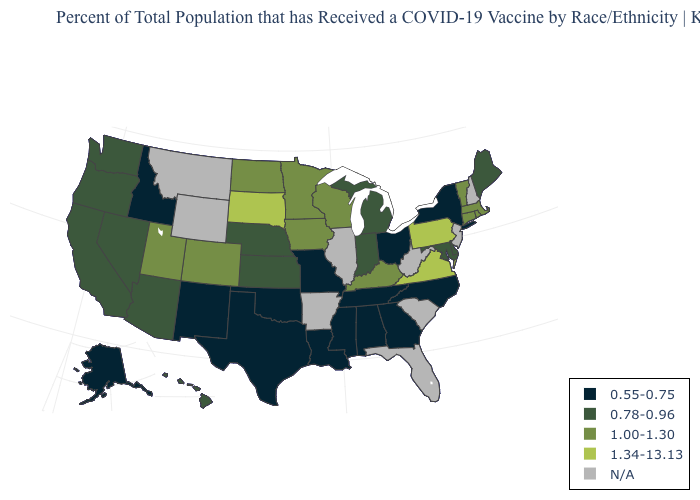What is the highest value in the USA?
Short answer required. 1.34-13.13. Does Colorado have the highest value in the West?
Give a very brief answer. Yes. What is the value of Colorado?
Be succinct. 1.00-1.30. Does Kentucky have the highest value in the South?
Short answer required. No. What is the highest value in the USA?
Quick response, please. 1.34-13.13. Which states hav the highest value in the MidWest?
Write a very short answer. South Dakota. Which states have the lowest value in the USA?
Answer briefly. Alabama, Alaska, Georgia, Idaho, Louisiana, Mississippi, Missouri, New Mexico, New York, North Carolina, Ohio, Oklahoma, Tennessee, Texas. Name the states that have a value in the range 1.00-1.30?
Write a very short answer. Colorado, Connecticut, Iowa, Kentucky, Massachusetts, Minnesota, North Dakota, Rhode Island, Utah, Vermont, Wisconsin. Name the states that have a value in the range 0.55-0.75?
Concise answer only. Alabama, Alaska, Georgia, Idaho, Louisiana, Mississippi, Missouri, New Mexico, New York, North Carolina, Ohio, Oklahoma, Tennessee, Texas. Does the map have missing data?
Write a very short answer. Yes. How many symbols are there in the legend?
Concise answer only. 5. Name the states that have a value in the range N/A?
Short answer required. Arkansas, Florida, Illinois, Montana, New Hampshire, New Jersey, South Carolina, West Virginia, Wyoming. What is the value of Iowa?
Short answer required. 1.00-1.30. 